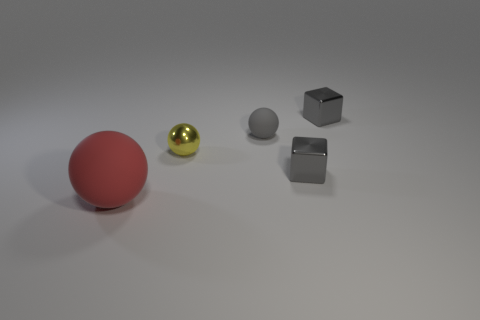Subtract all tiny balls. How many balls are left? 1 Add 4 big green shiny things. How many objects exist? 9 Subtract 2 cubes. How many cubes are left? 0 Subtract all gray spheres. How many spheres are left? 2 Subtract all blocks. How many objects are left? 3 Subtract all cyan cubes. Subtract all blue spheres. How many cubes are left? 2 Subtract all green cylinders. How many red balls are left? 1 Subtract all yellow metal objects. Subtract all green matte cylinders. How many objects are left? 4 Add 1 big objects. How many big objects are left? 2 Add 1 large blue matte blocks. How many large blue matte blocks exist? 1 